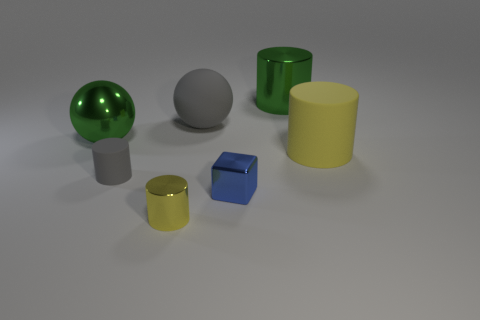Subtract 1 cylinders. How many cylinders are left? 3 Add 2 purple balls. How many objects exist? 9 Subtract all cylinders. How many objects are left? 3 Subtract all tiny blue cylinders. Subtract all tiny shiny blocks. How many objects are left? 6 Add 4 large matte cylinders. How many large matte cylinders are left? 5 Add 1 green cylinders. How many green cylinders exist? 2 Subtract 0 green blocks. How many objects are left? 7 